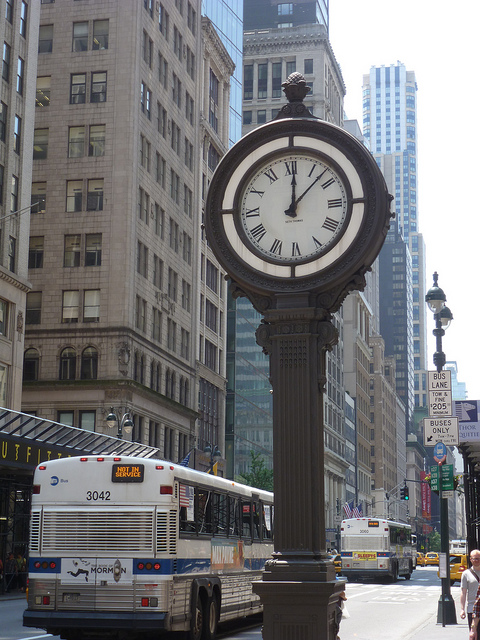Extract all visible text content from this image. XII XI X IX ONLY 205 LAKE BUS 3042 SERVICE HOT MORMAN VIII VII V III I 